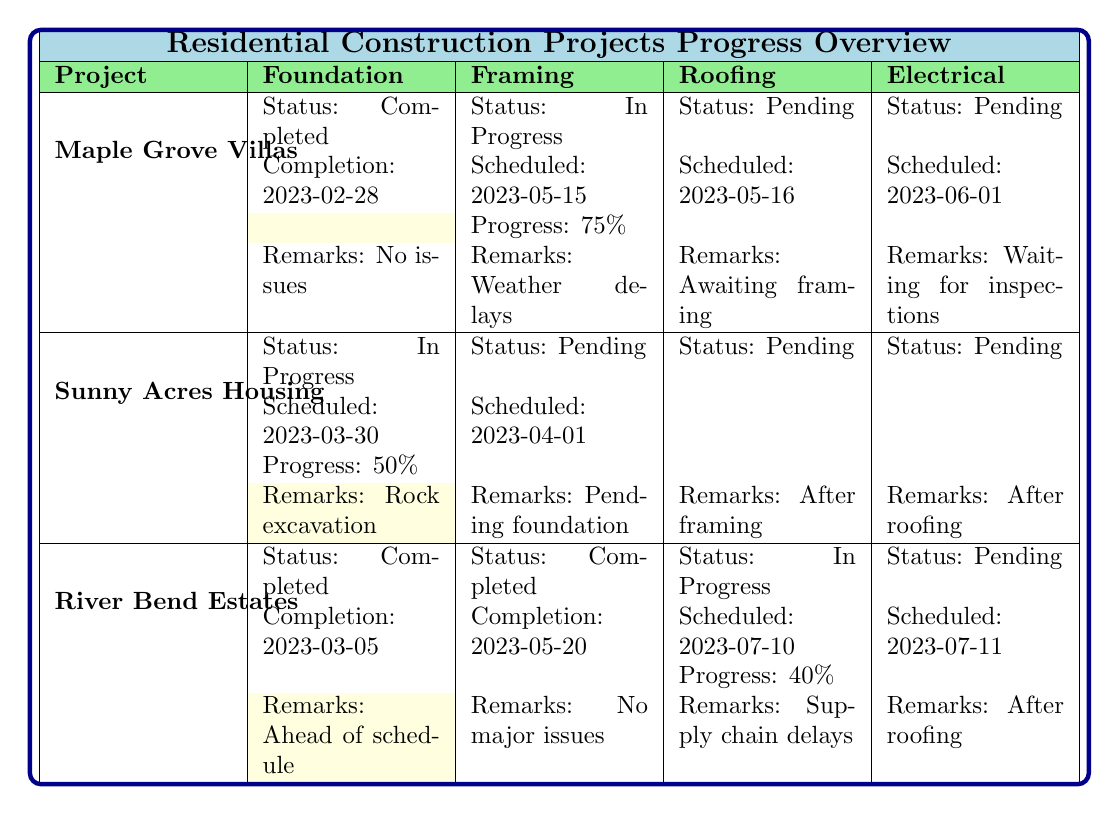What's the status of the Framing for Maple Grove Villas? The table shows that the Framing status for Maple Grove Villas is "In Progress."
Answer: In Progress What is the completion date for the Foundation of River Bend Estates? According to the table, the completion date for the Foundation of River Bend Estates is "2023-03-05."
Answer: 2023-03-05 Is the Electrical work scheduled to start after Roofing for Sunny Acres Housing? The table states that the Electrical work for Sunny Acres Housing is scheduled "after roofing," confirming that the Electrical work will indeed start after Roofing.
Answer: Yes What is the difference in progress percentage between Framing in Maple Grove Villas and River Bend Estates? Maple Grove Villas has a Framing progress of 75%, while River Bend Estates has completed Framing, so its progress percentage is 100%. The difference is calculated as 100% - 75% = 25%.
Answer: 25% Which project has the earliest expected completion date? The expected completion date for Maple Grove Villas is "2023-12-15," for Sunny Acres Housing it is "2024-02-28," and for River Bend Estates, it is "2023-11-10." Comparing these dates, Maple Grove Villas has the earliest expected completion date.
Answer: Maple Grove Villas What percentage of Roofing is complete in River Bend Estates? The table indicates that the Roofing for River Bend Estates is "In Progress" with a "Progress Percentage" of 40%, meaning that 40% of the Roofing task has been completed.
Answer: 40% What remarks are noted for the Framing status in Sunny Acres Housing? The table shows that the remarks for Framing in Sunny Acres Housing are "Pending foundation completion," indicating a delay in starting this task until the foundation is completed.
Answer: Pending foundation completion How many projects have their Foundation work marked as Completed? In the table, Maple Grove Villas and River Bend Estates both have their Foundation work marked as "Completed," while Sunny Acres Housing has its Foundation work "In Progress." Thus, there are two projects with completed Foundation work.
Answer: 2 What is the scheduled start date for Electrical work in River Bend Estates? The table states that the Electrical work for River Bend Estates is scheduled to start on "2023-07-11," which indicates the planned start date after the roofing is finished.
Answer: 2023-07-11 